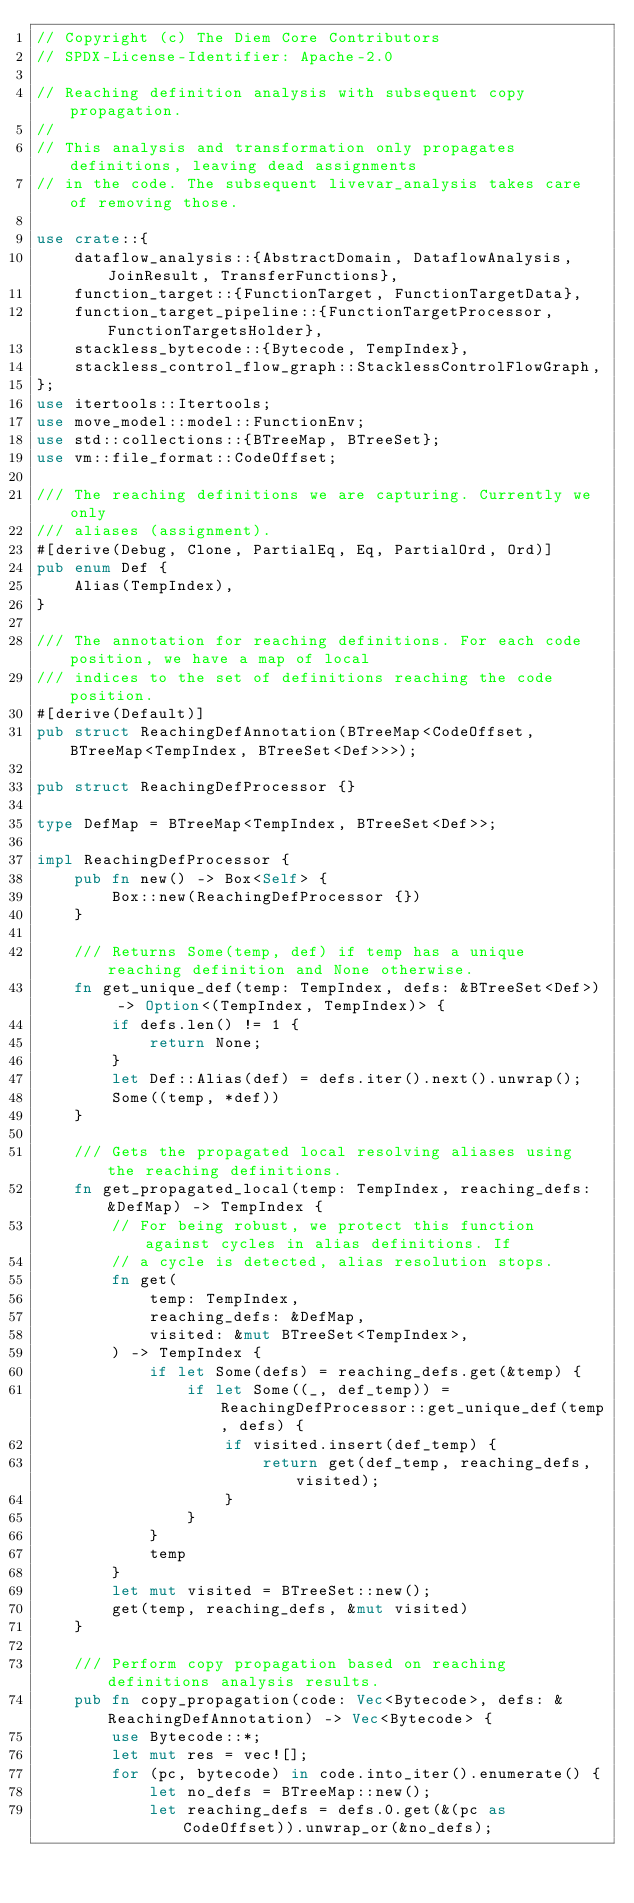<code> <loc_0><loc_0><loc_500><loc_500><_Rust_>// Copyright (c) The Diem Core Contributors
// SPDX-License-Identifier: Apache-2.0

// Reaching definition analysis with subsequent copy propagation.
//
// This analysis and transformation only propagates definitions, leaving dead assignments
// in the code. The subsequent livevar_analysis takes care of removing those.

use crate::{
    dataflow_analysis::{AbstractDomain, DataflowAnalysis, JoinResult, TransferFunctions},
    function_target::{FunctionTarget, FunctionTargetData},
    function_target_pipeline::{FunctionTargetProcessor, FunctionTargetsHolder},
    stackless_bytecode::{Bytecode, TempIndex},
    stackless_control_flow_graph::StacklessControlFlowGraph,
};
use itertools::Itertools;
use move_model::model::FunctionEnv;
use std::collections::{BTreeMap, BTreeSet};
use vm::file_format::CodeOffset;

/// The reaching definitions we are capturing. Currently we only
/// aliases (assignment).
#[derive(Debug, Clone, PartialEq, Eq, PartialOrd, Ord)]
pub enum Def {
    Alias(TempIndex),
}

/// The annotation for reaching definitions. For each code position, we have a map of local
/// indices to the set of definitions reaching the code position.
#[derive(Default)]
pub struct ReachingDefAnnotation(BTreeMap<CodeOffset, BTreeMap<TempIndex, BTreeSet<Def>>>);

pub struct ReachingDefProcessor {}

type DefMap = BTreeMap<TempIndex, BTreeSet<Def>>;

impl ReachingDefProcessor {
    pub fn new() -> Box<Self> {
        Box::new(ReachingDefProcessor {})
    }

    /// Returns Some(temp, def) if temp has a unique reaching definition and None otherwise.
    fn get_unique_def(temp: TempIndex, defs: &BTreeSet<Def>) -> Option<(TempIndex, TempIndex)> {
        if defs.len() != 1 {
            return None;
        }
        let Def::Alias(def) = defs.iter().next().unwrap();
        Some((temp, *def))
    }

    /// Gets the propagated local resolving aliases using the reaching definitions.
    fn get_propagated_local(temp: TempIndex, reaching_defs: &DefMap) -> TempIndex {
        // For being robust, we protect this function against cycles in alias definitions. If
        // a cycle is detected, alias resolution stops.
        fn get(
            temp: TempIndex,
            reaching_defs: &DefMap,
            visited: &mut BTreeSet<TempIndex>,
        ) -> TempIndex {
            if let Some(defs) = reaching_defs.get(&temp) {
                if let Some((_, def_temp)) = ReachingDefProcessor::get_unique_def(temp, defs) {
                    if visited.insert(def_temp) {
                        return get(def_temp, reaching_defs, visited);
                    }
                }
            }
            temp
        }
        let mut visited = BTreeSet::new();
        get(temp, reaching_defs, &mut visited)
    }

    /// Perform copy propagation based on reaching definitions analysis results.
    pub fn copy_propagation(code: Vec<Bytecode>, defs: &ReachingDefAnnotation) -> Vec<Bytecode> {
        use Bytecode::*;
        let mut res = vec![];
        for (pc, bytecode) in code.into_iter().enumerate() {
            let no_defs = BTreeMap::new();
            let reaching_defs = defs.0.get(&(pc as CodeOffset)).unwrap_or(&no_defs);</code> 